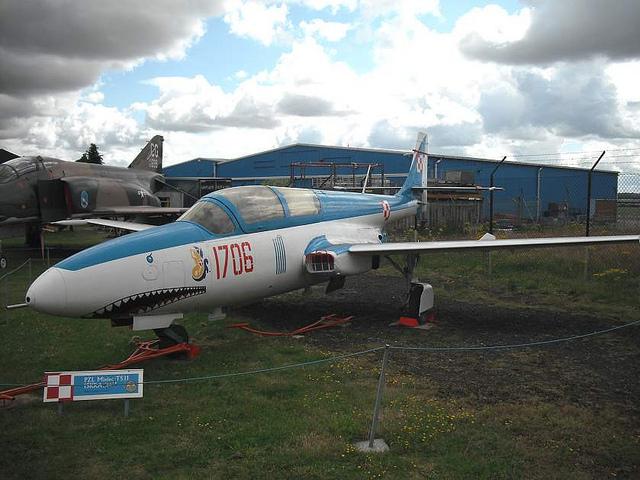What animal does this plane look like?
Quick response, please. Shark. What is surrounding the field?
Short answer required. Fence. Is that a private plane?
Answer briefly. Yes. Where is the plane?
Concise answer only. Ground. 